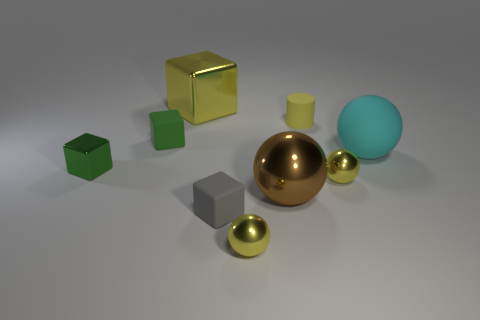Can you tell me what the largest object in the scene is made out of? The largest object in the image seems to be a sphere with a highly-reflective surface, indicative of polished metal, such as chrome or steel. 